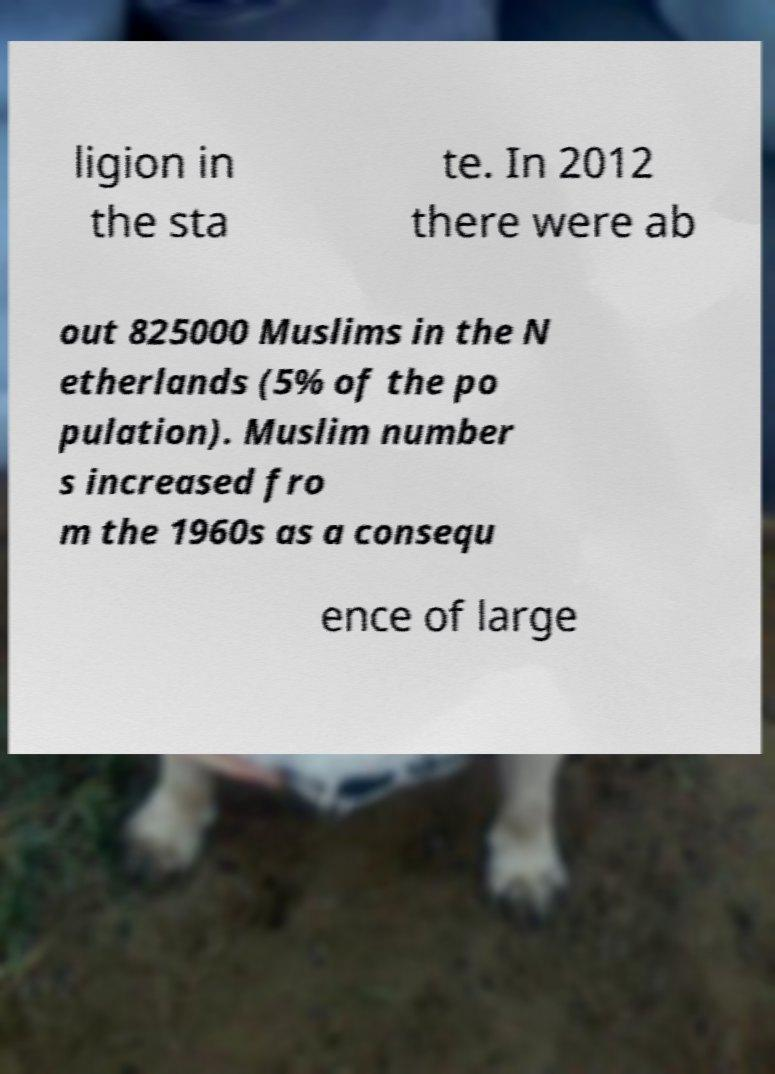What messages or text are displayed in this image? I need them in a readable, typed format. ligion in the sta te. In 2012 there were ab out 825000 Muslims in the N etherlands (5% of the po pulation). Muslim number s increased fro m the 1960s as a consequ ence of large 